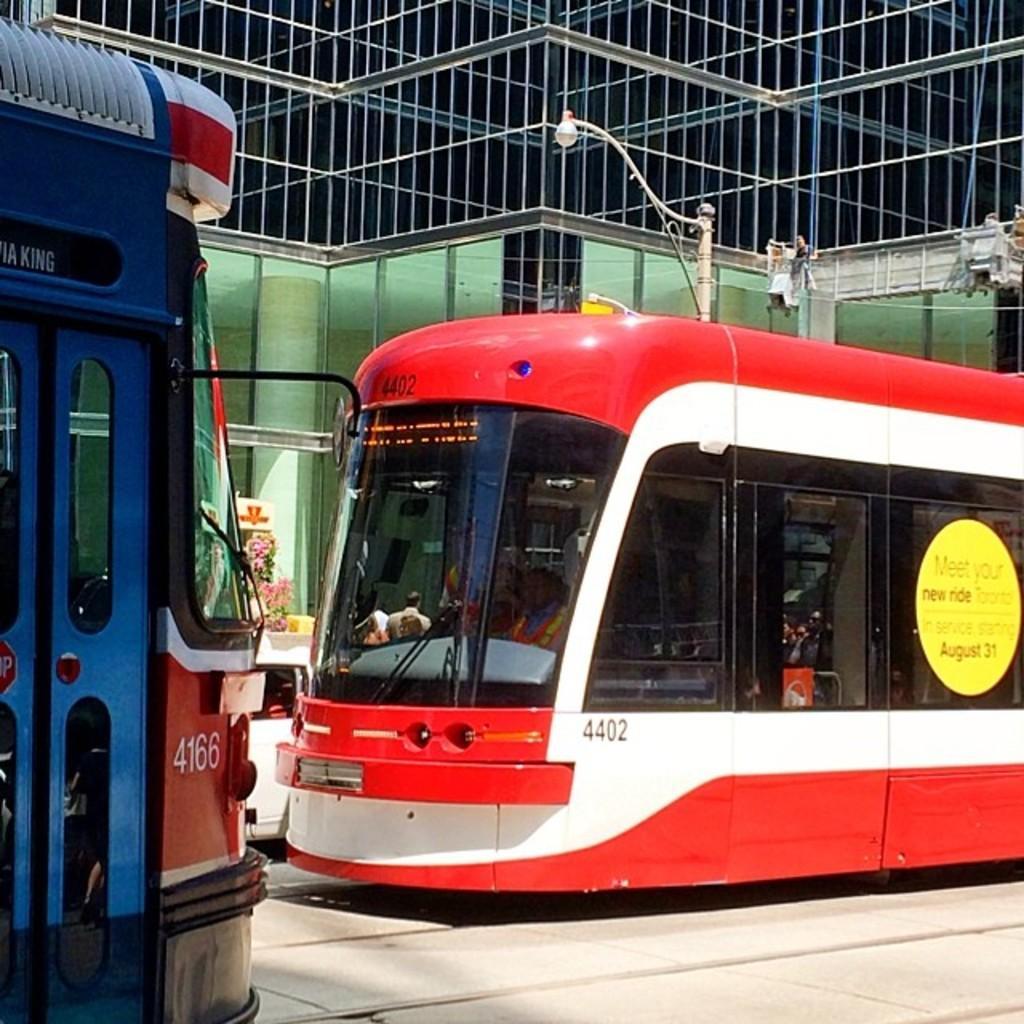Please provide a concise description of this image. In this picture we can see two red color bullet trains parked in the station. Behind there is a glass frame. 